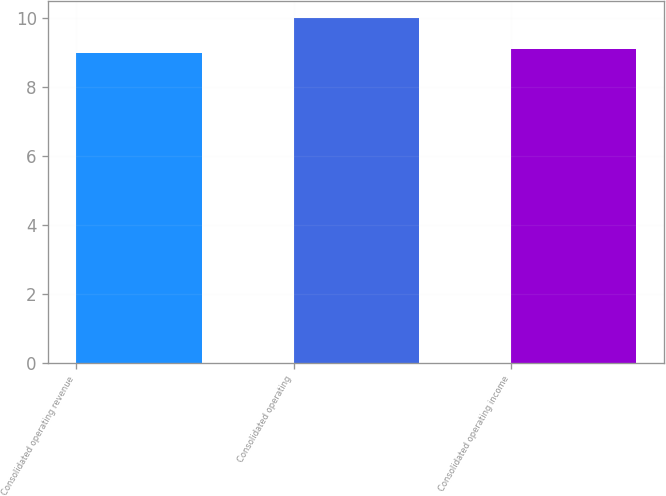<chart> <loc_0><loc_0><loc_500><loc_500><bar_chart><fcel>Consolidated operating revenue<fcel>Consolidated operating<fcel>Consolidated operating income<nl><fcel>9<fcel>10<fcel>9.1<nl></chart> 